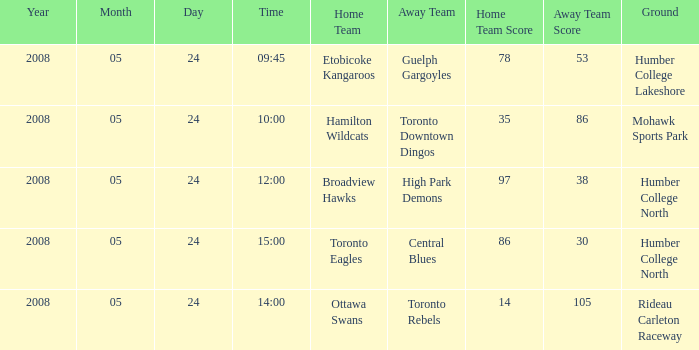On what day was the game that ended in a score of 97-38? 2008-05-24. 